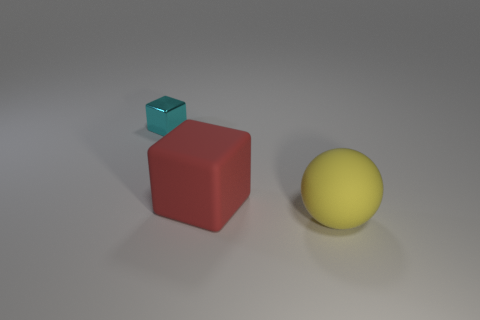Add 2 small cyan metal objects. How many objects exist? 5 Subtract all cubes. How many objects are left? 1 Subtract 1 cubes. How many cubes are left? 1 Add 2 small matte cylinders. How many small matte cylinders exist? 2 Subtract 0 blue cylinders. How many objects are left? 3 Subtract all gray blocks. Subtract all green balls. How many blocks are left? 2 Subtract all blue blocks. How many red balls are left? 0 Subtract all matte blocks. Subtract all matte objects. How many objects are left? 0 Add 3 large yellow rubber balls. How many large yellow rubber balls are left? 4 